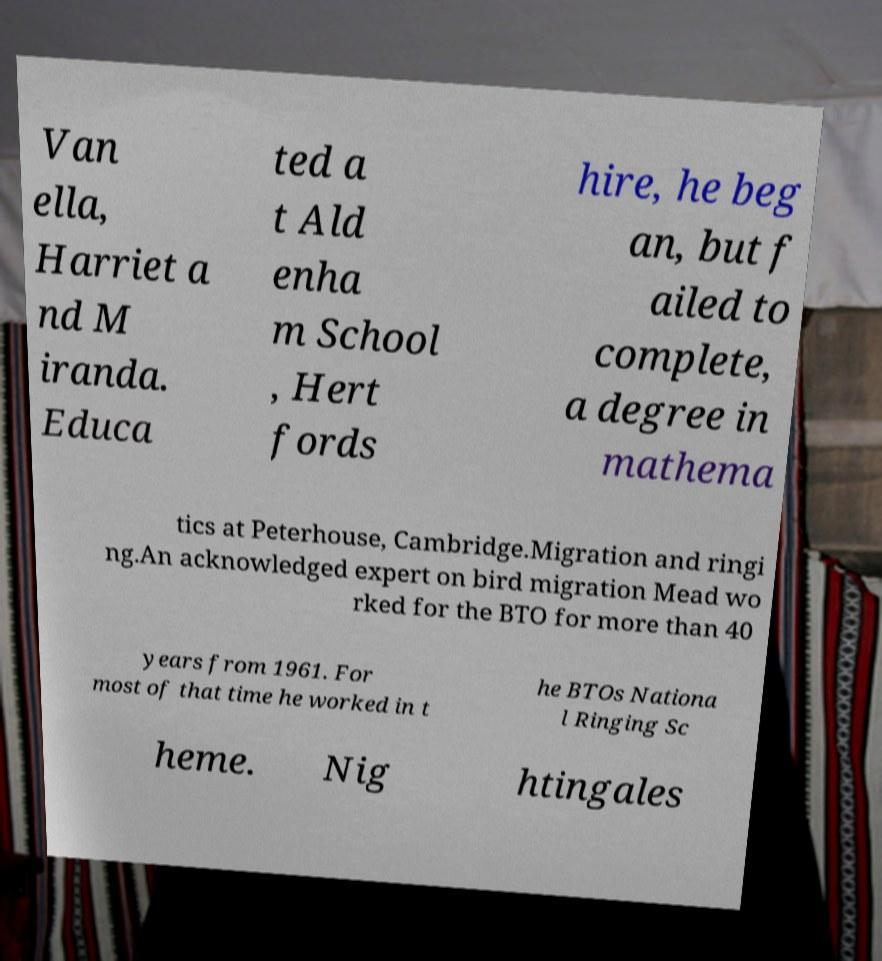Could you assist in decoding the text presented in this image and type it out clearly? Van ella, Harriet a nd M iranda. Educa ted a t Ald enha m School , Hert fords hire, he beg an, but f ailed to complete, a degree in mathema tics at Peterhouse, Cambridge.Migration and ringi ng.An acknowledged expert on bird migration Mead wo rked for the BTO for more than 40 years from 1961. For most of that time he worked in t he BTOs Nationa l Ringing Sc heme. Nig htingales 